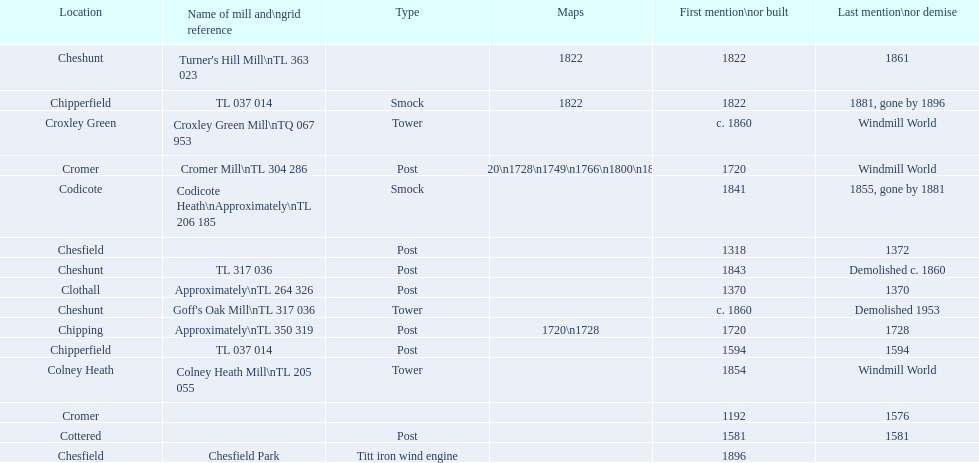How man "c" windmills have there been? 15. 